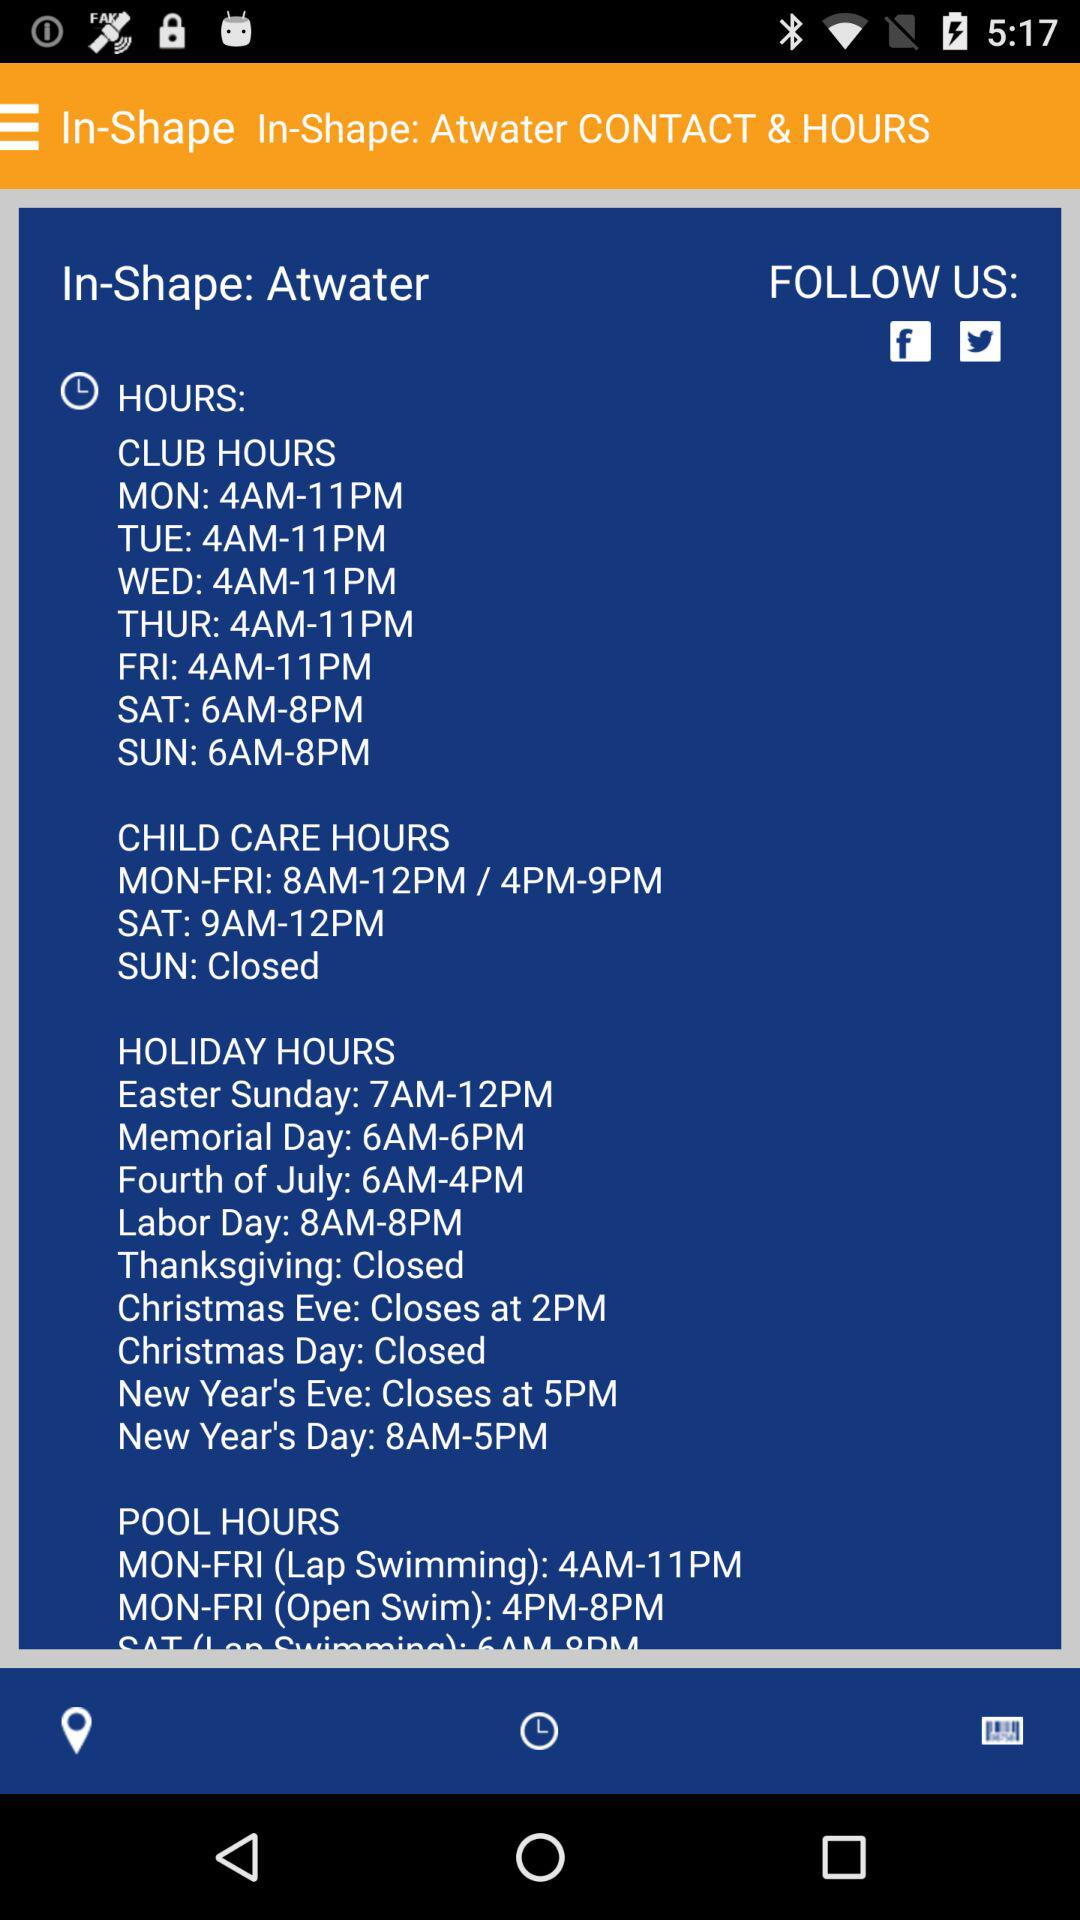What is the timing of pool hours for "Lap Swimming"? The time is from 4 a.m. to 11 p.m. 